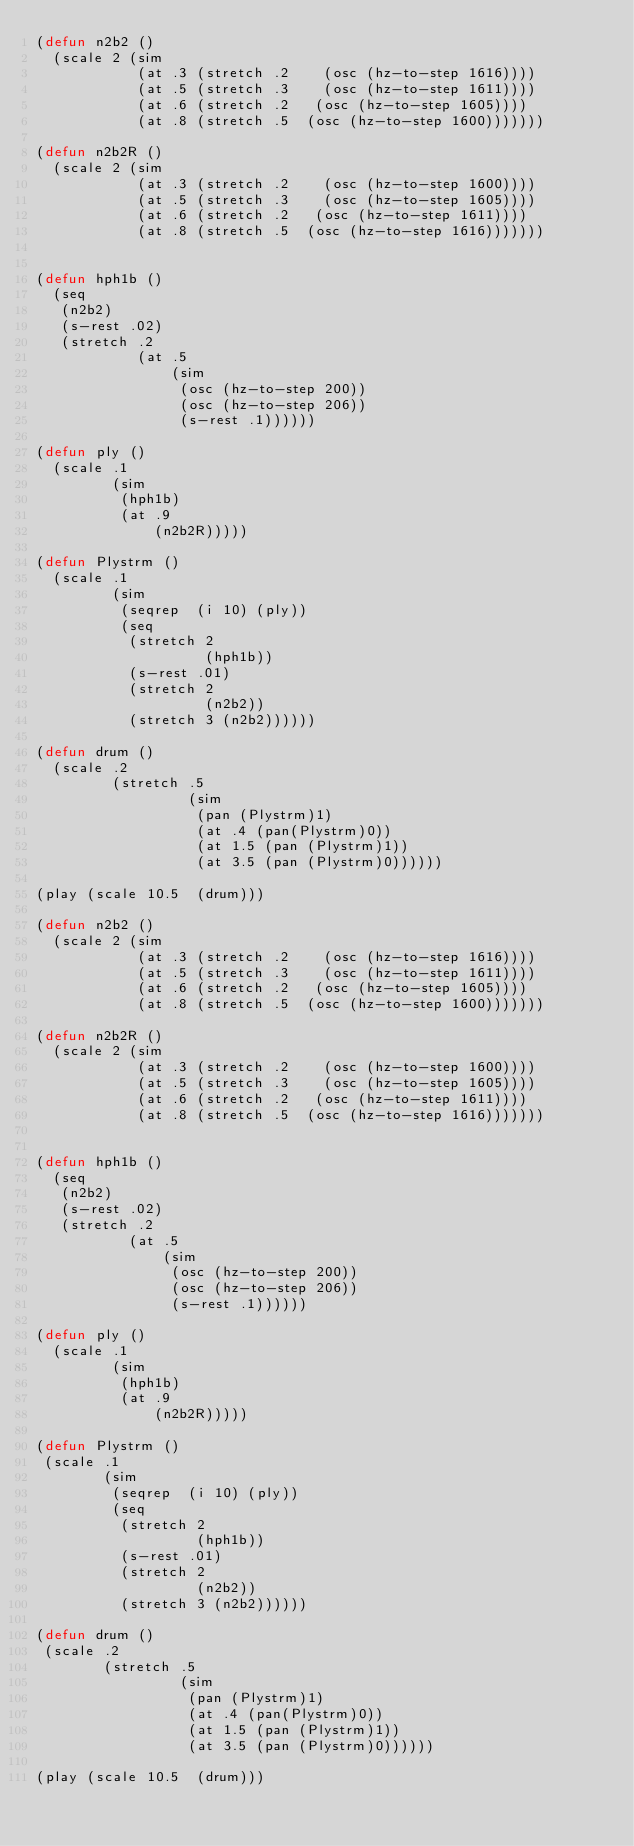Convert code to text. <code><loc_0><loc_0><loc_500><loc_500><_Lisp_>(defun n2b2 ()
  (scale 2 (sim
            (at .3 (stretch .2    (osc (hz-to-step 1616))))
            (at .5 (stretch .3    (osc (hz-to-step 1611))))
            (at .6 (stretch .2   (osc (hz-to-step 1605))))
            (at .8 (stretch .5  (osc (hz-to-step 1600)))))))

(defun n2b2R ()
  (scale 2 (sim
            (at .3 (stretch .2    (osc (hz-to-step 1600))))
            (at .5 (stretch .3    (osc (hz-to-step 1605))))
            (at .6 (stretch .2   (osc (hz-to-step 1611))))
            (at .8 (stretch .5  (osc (hz-to-step 1616)))))))


(defun hph1b ()
  (seq
   (n2b2)
   (s-rest .02)
   (stretch .2
            (at .5
                (sim
                 (osc (hz-to-step 200))
                 (osc (hz-to-step 206))
                 (s-rest .1))))))
           
(defun ply ()
  (scale .1
         (sim
          (hph1b)
          (at .9
              (n2b2R)))))

(defun Plystrm ()
  (scale .1
         (sim
          (seqrep  (i 10) (ply))
          (seq
           (stretch 2
                    (hph1b))
           (s-rest .01)
           (stretch 2
                    (n2b2))
           (stretch 3 (n2b2))))))

(defun drum ()
  (scale .2
         (stretch .5
                  (sim
                   (pan (Plystrm)1)
                   (at .4 (pan(Plystrm)0))
                   (at 1.5 (pan (Plystrm)1))
                   (at 3.5 (pan (Plystrm)0))))))

(play (scale 10.5  (drum)))

(defun n2b2 ()
  (scale 2 (sim
            (at .3 (stretch .2    (osc (hz-to-step 1616))))
            (at .5 (stretch .3    (osc (hz-to-step 1611))))
            (at .6 (stretch .2   (osc (hz-to-step 1605))))
            (at .8 (stretch .5  (osc (hz-to-step 1600)))))))

(defun n2b2R ()
  (scale 2 (sim
            (at .3 (stretch .2    (osc (hz-to-step 1600))))
            (at .5 (stretch .3    (osc (hz-to-step 1605))))
            (at .6 (stretch .2   (osc (hz-to-step 1611))))
            (at .8 (stretch .5  (osc (hz-to-step 1616)))))))


(defun hph1b ()
  (seq
   (n2b2)
   (s-rest .02)
   (stretch .2
           (at .5
               (sim
                (osc (hz-to-step 200))
                (osc (hz-to-step 206))
                (s-rest .1))))))
           
(defun ply ()
  (scale .1
         (sim
          (hph1b)
          (at .9
              (n2b2R)))))

(defun Plystrm ()
 (scale .1
        (sim
         (seqrep  (i 10) (ply))
         (seq
          (stretch 2
                   (hph1b))
          (s-rest .01)
          (stretch 2
                   (n2b2))
          (stretch 3 (n2b2))))))

(defun drum ()
 (scale .2
        (stretch .5
                 (sim
                  (pan (Plystrm)1)
                  (at .4 (pan(Plystrm)0))
                  (at 1.5 (pan (Plystrm)1))
                  (at 3.5 (pan (Plystrm)0))))))

(play (scale 10.5  (drum)))

</code> 